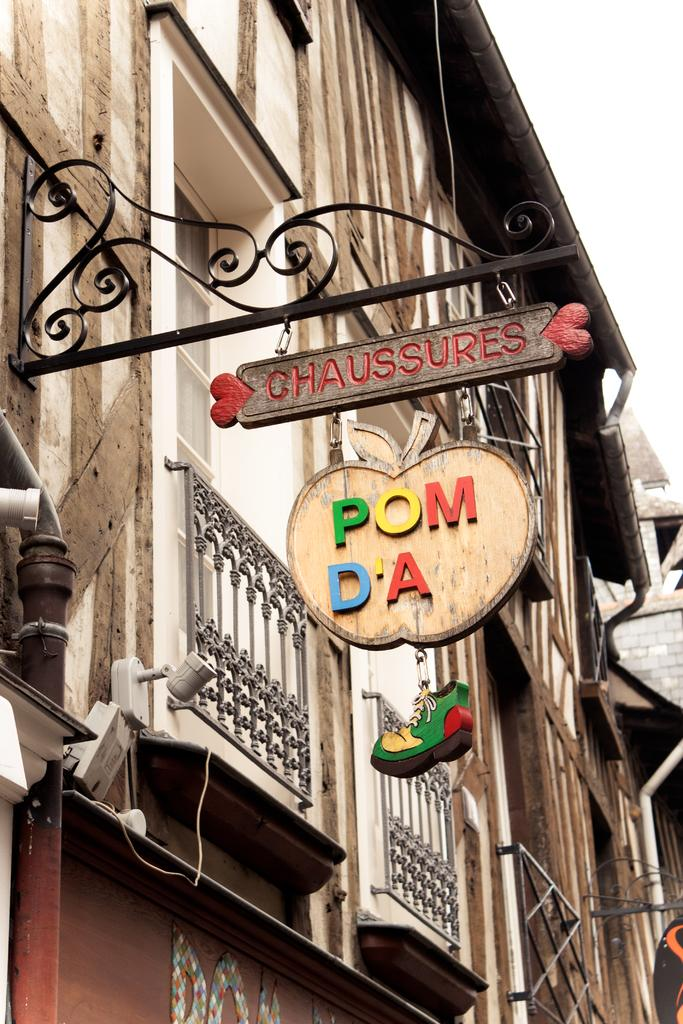<image>
Present a compact description of the photo's key features. A sign hanging outside a store reads chaussures. 